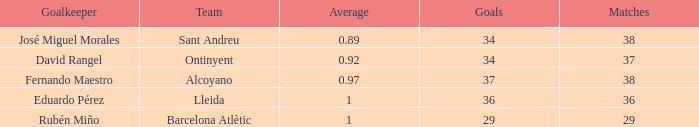What is the sum of Goals, when Matches is less than 29? None. 